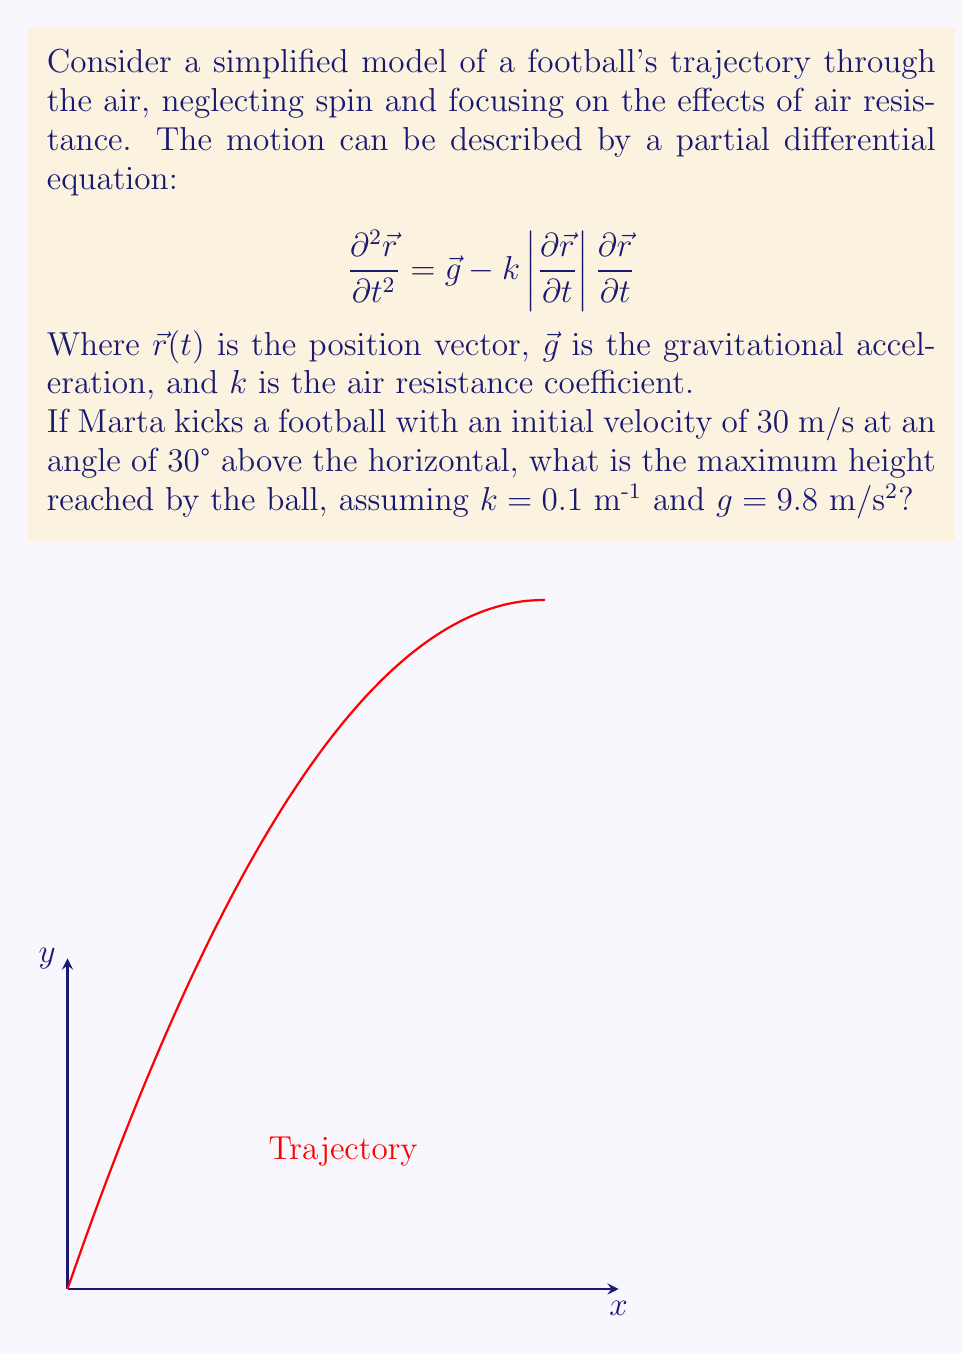Teach me how to tackle this problem. To solve this problem, we need to follow these steps:

1) First, we need to simplify our model. For the maximum height, we only need to consider the vertical component of motion.

2) The vertical component of the initial velocity is:
   $$v_{0y} = 30 \cdot \sin(30°) = 15 \text{ m/s}$$

3) The time to reach the maximum height is when the vertical velocity becomes zero. We can find this using the equation:
   $$\frac{dv_y}{dt} = -g - kv_y^2$$

4) This is a nonlinear differential equation. For a precise solution, we would need to solve it numerically. However, for an approximate solution, we can use the equation for motion without air resistance and then apply a correction factor.

5) Without air resistance, the time to reach maximum height would be:
   $$t_{\text{max}} = \frac{v_{0y}}{g} = \frac{15}{9.8} \approx 1.53 \text{ s}$$

6) The maximum height without air resistance would be:
   $$h_{\text{max}} = \frac{v_{0y}^2}{2g} = \frac{15^2}{2(9.8)} \approx 11.48 \text{ m}$$

7) To account for air resistance, we can apply a correction factor. A common approximation is:
   $$h_{\text{max, with drag}} \approx h_{\text{max}} \cdot e^{-kv_{0y}/g}$$

8) Plugging in our values:
   $$h_{\text{max, with drag}} \approx 11.48 \cdot e^{-0.1 \cdot 15 / 9.8} \approx 9.76 \text{ m}$$

This is an approximation, but it gives us a reasonable estimate of the maximum height considering air resistance.
Answer: $$9.76 \text{ m}$$ 